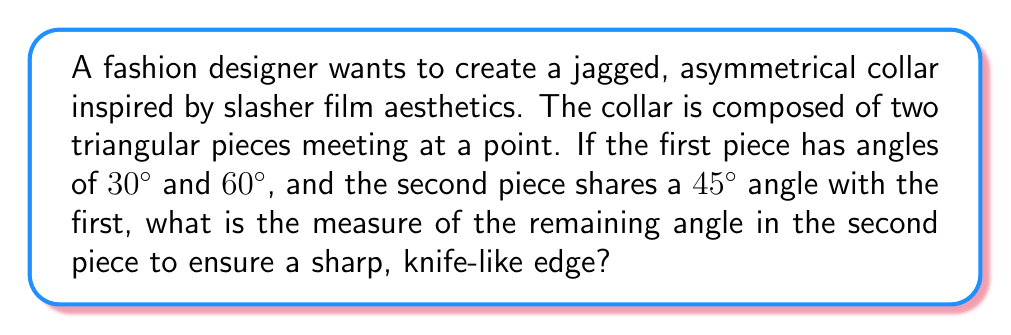What is the answer to this math problem? Let's approach this step-by-step:

1) First, recall that the sum of angles in a triangle is always 180°.

2) For the first triangular piece:
   We know two angles: 30° and 60°
   Let's call the third angle $x$
   $$30° + 60° + x = 180°$$
   $$90° + x = 180°$$
   $$x = 90°$$

3) Now for the second triangular piece:
   We know it shares a 45° angle with the first piece
   Let's call the unknown angle $y$

4) We can set up another equation:
   $$45° + 90° + y = 180°$$
   
5) Simplify:
   $$135° + y = 180°$$
   
6) Solve for $y$:
   $$y = 180° - 135° = 45°$$

Therefore, the remaining angle in the second piece should be 45°.

[asy]
unitsize(1cm);

pair A = (0,0);
pair B = (5,0);
pair C = (2.5,4.33);
pair D = (2.5,-2);

draw(A--B--C--cycle);
draw(A--B--D--cycle);

label("30°", A, SW);
label("60°", B, SE);
label("90°", C, N);
label("45°", (A+D)/2, E);
label("45°", (B+D)/2, W);
label("90°", D, S);

[/asy]
Answer: 45° 